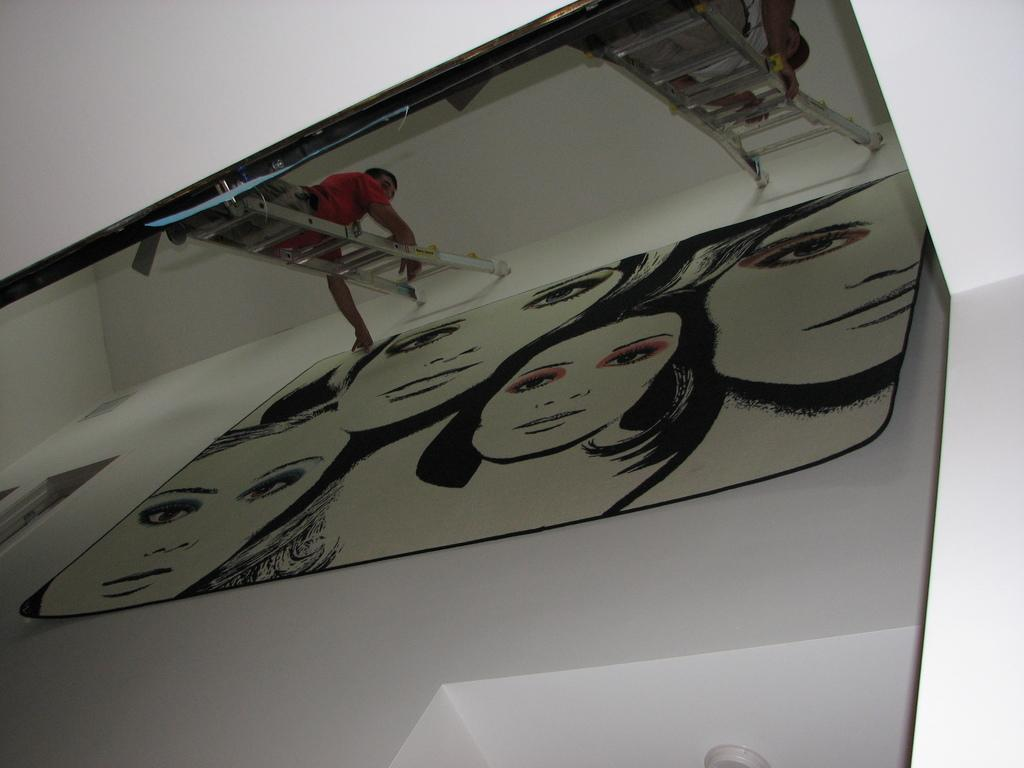What are the persons in the image doing? A: The persons in the image are standing on extendable ladders. What can be seen on the wall in the image? There are wall hangings on the wall in the image. What route are the cattle taking in the image? There are no cattle present in the image, so there is no route to describe. 